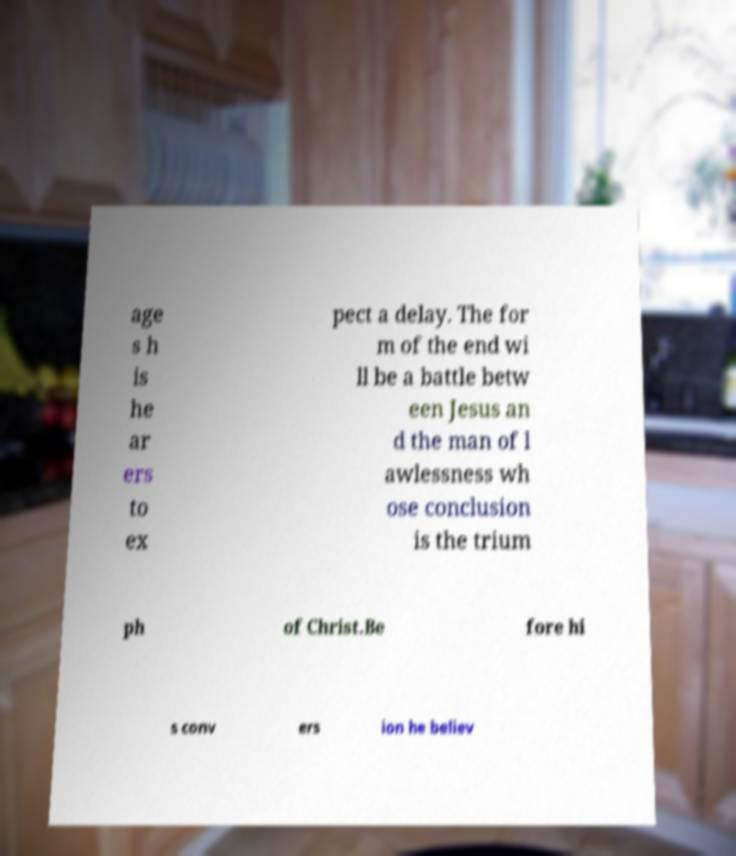Could you extract and type out the text from this image? age s h is he ar ers to ex pect a delay. The for m of the end wi ll be a battle betw een Jesus an d the man of l awlessness wh ose conclusion is the trium ph of Christ.Be fore hi s conv ers ion he believ 